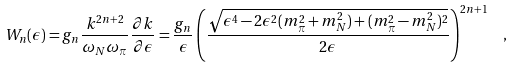<formula> <loc_0><loc_0><loc_500><loc_500>W _ { n } ( \epsilon ) = g _ { n } \frac { k ^ { 2 n + 2 } } { \omega _ { N } \omega _ { \pi } } \frac { \partial k } { \partial \epsilon } = \frac { g _ { n } } { \epsilon } \left ( \frac { \sqrt { \epsilon ^ { 4 } - 2 \epsilon ^ { 2 } ( m _ { \pi } ^ { 2 } + m _ { N } ^ { 2 } ) + ( m _ { \pi } ^ { 2 } - m _ { N } ^ { 2 } ) ^ { 2 } } } { 2 \epsilon } \right ) ^ { 2 n + 1 } \ \ ,</formula> 